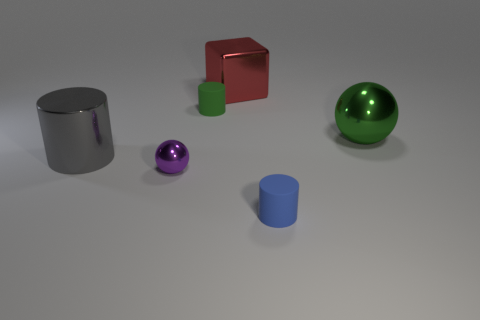Do the large shiny sphere and the matte cylinder on the left side of the red shiny object have the same color?
Your response must be concise. Yes. What material is the small sphere that is to the left of the small rubber cylinder that is in front of the green rubber thing?
Offer a very short reply. Metal. Do the blue thing and the purple thing have the same size?
Make the answer very short. Yes. How many things are either matte cylinders or small blue matte balls?
Your response must be concise. 2. There is a thing that is in front of the large shiny cylinder and on the left side of the tiny blue matte cylinder; how big is it?
Your answer should be very brief. Small. Is the number of small green cylinders that are to the right of the block less than the number of green balls?
Offer a very short reply. Yes. There is a gray thing that is the same material as the big red cube; what is its shape?
Provide a succinct answer. Cylinder. There is a large gray object to the left of the purple metal thing; is it the same shape as the big object that is behind the large green shiny object?
Offer a terse response. No. Are there fewer big red things on the right side of the big red block than things that are behind the metal cylinder?
Provide a succinct answer. Yes. The thing that is the same color as the large metallic ball is what shape?
Your answer should be compact. Cylinder. 